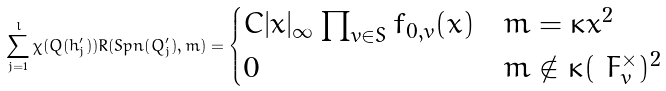<formula> <loc_0><loc_0><loc_500><loc_500>\sum _ { j = 1 } ^ { l } \chi ( Q ( h ^ { \prime } _ { j } ) ) R ( S p n ( Q ^ { \prime } _ { j } ) , m ) = \begin{cases} C | x | _ { \infty } \prod _ { v \in S } f _ { 0 , v } ( x ) & m = \kappa x ^ { 2 } \\ 0 & m \notin \kappa ( \ F _ { v } ^ { \times } ) ^ { 2 } \end{cases}</formula> 